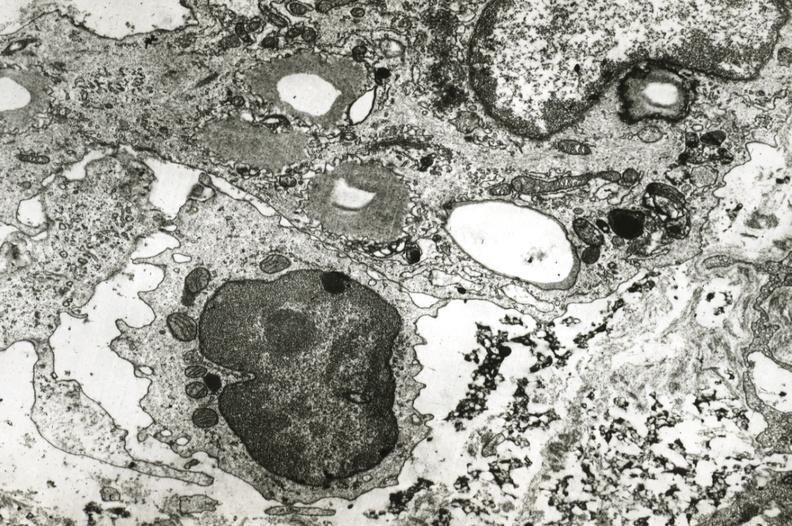s macerated stillborn present?
Answer the question using a single word or phrase. No 